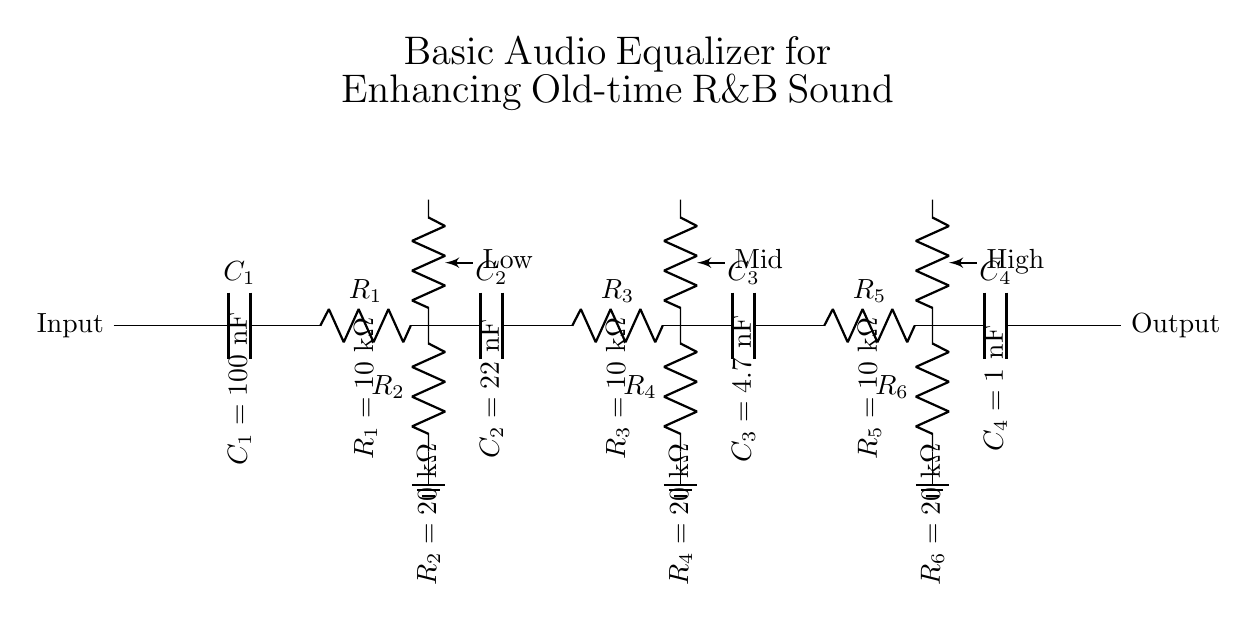What is the input component in this circuit? The input component is the capacitor labeled C1, which initially collects the signal before processing.
Answer: C1 How many frequency stages are represented in the circuit? The circuit has three frequency stages: low, mid, and high, each composed of a resistor and capacitor.
Answer: Three What is the value of C2? C2 is specified as having a value of twenty-two nanofarads, which is indicated in the circuit annotations.
Answer: Twenty-two nanofarads Which resistors are part of the low frequency stage? The low frequency stage consists of R1 and R2, both of which shape the input signal at low frequencies.
Answer: R1 and R2 How do the potentiometers affect the circuit? The potentiometers adjust the signal levels at their respective frequency stages, allowing for enhancing or reducing bass, mid, and treble frequencies.
Answer: They adjust signal levels What is the role of C4 in this equalizer circuit? C4 functions to filter high-frequency signals, allowing only certain frequencies to pass through to the output while attenuating others.
Answer: Filtering high frequencies What happens to the sound quality when R2 is increased? Increasing R2 would typically reduce the gain in the low frequency stage, which could result in less bass response in the overall sound output.
Answer: Reduced bass response 